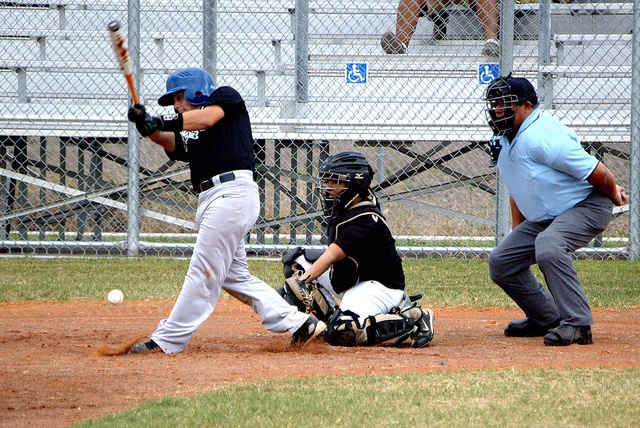Describe the objects in this image and their specific colors. I can see people in lightblue, black, gray, and darkgray tones, people in lightblue, lavender, black, and darkgray tones, people in lightblue, black, white, gray, and darkgray tones, people in lightblue, darkgray, gray, brown, and maroon tones, and bench in lightblue, lightgray, and darkgray tones in this image. 